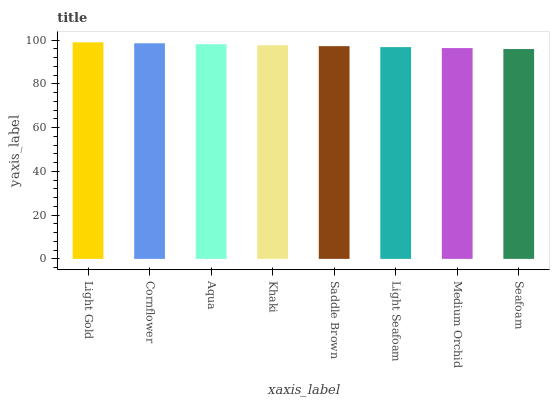Is Cornflower the minimum?
Answer yes or no. No. Is Cornflower the maximum?
Answer yes or no. No. Is Light Gold greater than Cornflower?
Answer yes or no. Yes. Is Cornflower less than Light Gold?
Answer yes or no. Yes. Is Cornflower greater than Light Gold?
Answer yes or no. No. Is Light Gold less than Cornflower?
Answer yes or no. No. Is Khaki the high median?
Answer yes or no. Yes. Is Saddle Brown the low median?
Answer yes or no. Yes. Is Cornflower the high median?
Answer yes or no. No. Is Light Seafoam the low median?
Answer yes or no. No. 